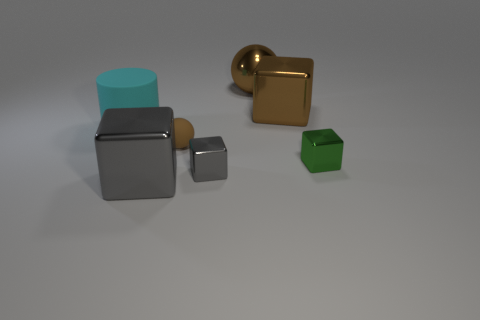Could you suggest the mood or theme represented by this arrangement? The image conveys a minimalist and contemporary mood, focusing on simplicity and geometric shapes. The clean lines, neutral background, and the deliberate but sparse placement of objects suggest a theme of modernism and perhaps an exploration of space and form. 